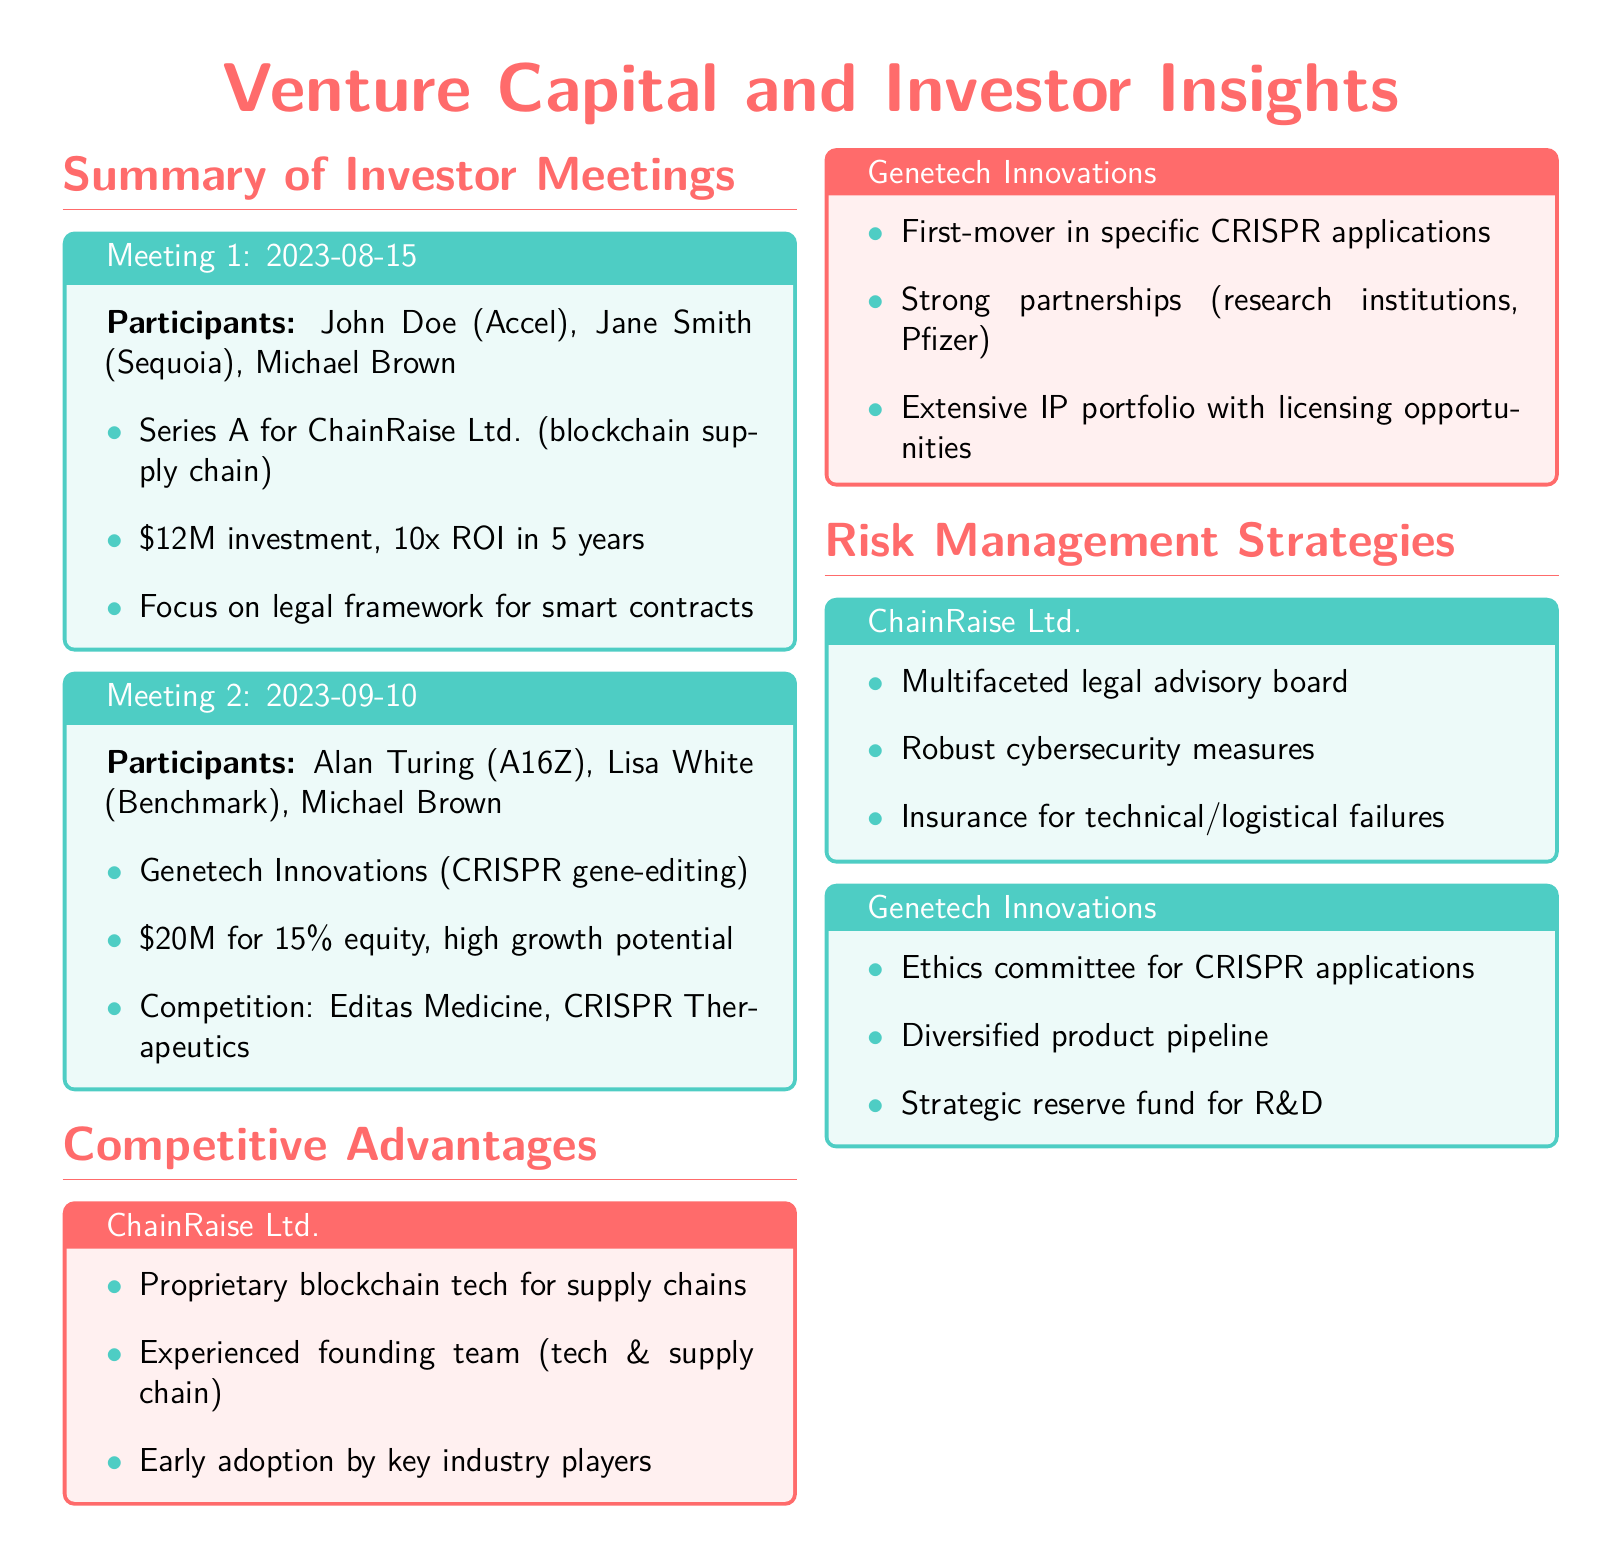What is the date of Meeting 1? The date of Meeting 1 is clearly mentioned in the title of the tcolorbox, which is 2023-08-15.
Answer: 2023-08-15 Who are the participants in Meeting 2? The participants for Meeting 2 are listed under the meeting details in the document, which include Alan Turing, Lisa White, and Michael Brown.
Answer: Alan Turing, Lisa White, Michael Brown What is the investment amount for ChainRaise Ltd.? The investment amount is specified in the summary of Meeting 1 as $12M.
Answer: $12M What competitive advantage does Genetech Innovations have? The document states that Genetech Innovations has a first-mover in specific CRISPR applications as a competitive advantage.
Answer: First-mover in specific CRISPR applications What is one risk management strategy for ChainRaise Ltd.? The document lists a multifaceted legal advisory board as one of the risk management strategies for ChainRaise Ltd.
Answer: Multifaceted legal advisory board What is the equity percentage offered for Genetech Innovations? The equity percentage for Genetech Innovations is mentioned as 15%.
Answer: 15% Which company focuses on blockchain supply chain technology? The summary of Meeting 1 indicates that ChainRaise Ltd. focuses on blockchain supply chain technology.
Answer: ChainRaise Ltd What is the total expected return on investment for ChainRaise Ltd.? The expected return on investment is mentioned as 10x ROI in 5 years.
Answer: 10x ROI in 5 years What type of innovations does Genetech Innovations specialize in? The document states that Genetech Innovations specializes in CRISPR gene-editing technologies.
Answer: CRISPR gene-editing 